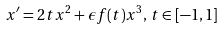<formula> <loc_0><loc_0><loc_500><loc_500>x ^ { \prime } = 2 t x ^ { 2 } + \epsilon f ( t ) x ^ { 3 } , \, t \in [ - 1 , 1 ]</formula> 